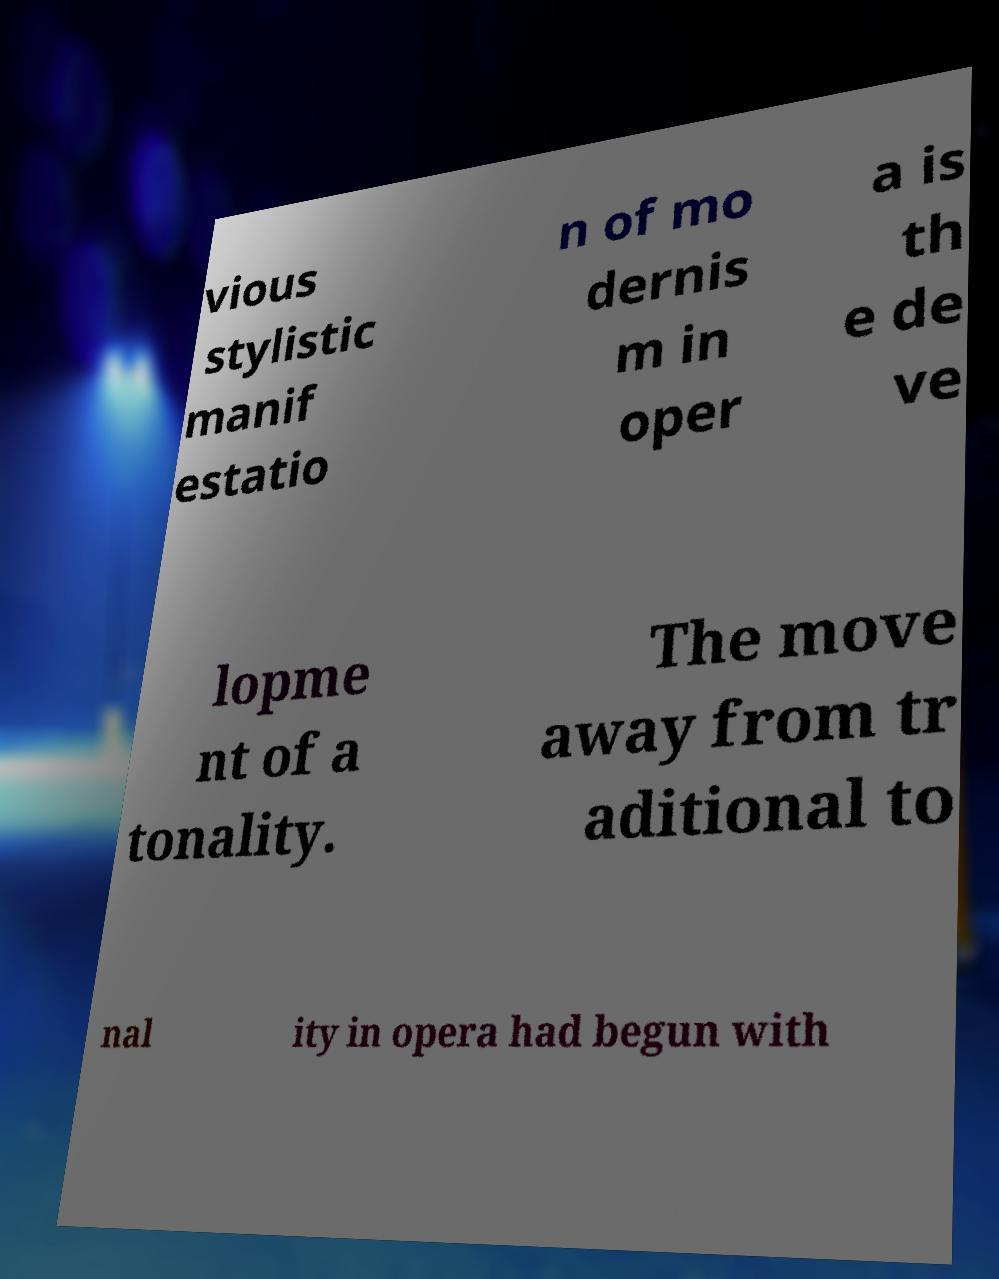Could you extract and type out the text from this image? vious stylistic manif estatio n of mo dernis m in oper a is th e de ve lopme nt of a tonality. The move away from tr aditional to nal ity in opera had begun with 